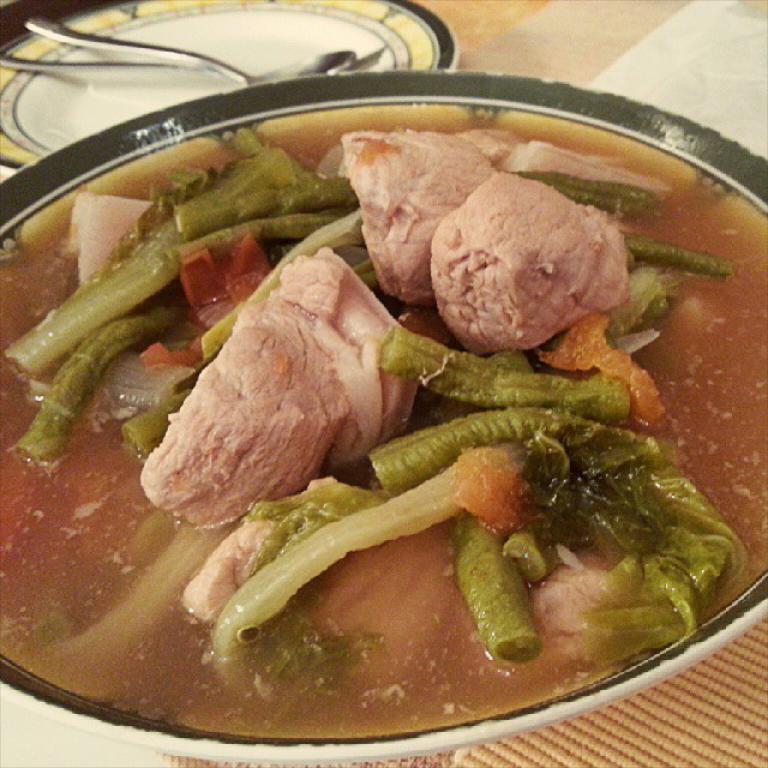Describe this image in one or two sentences. In this image we can see some food item which is in a bowl and at the background of the image there is plate in which there is spoon and fork. 